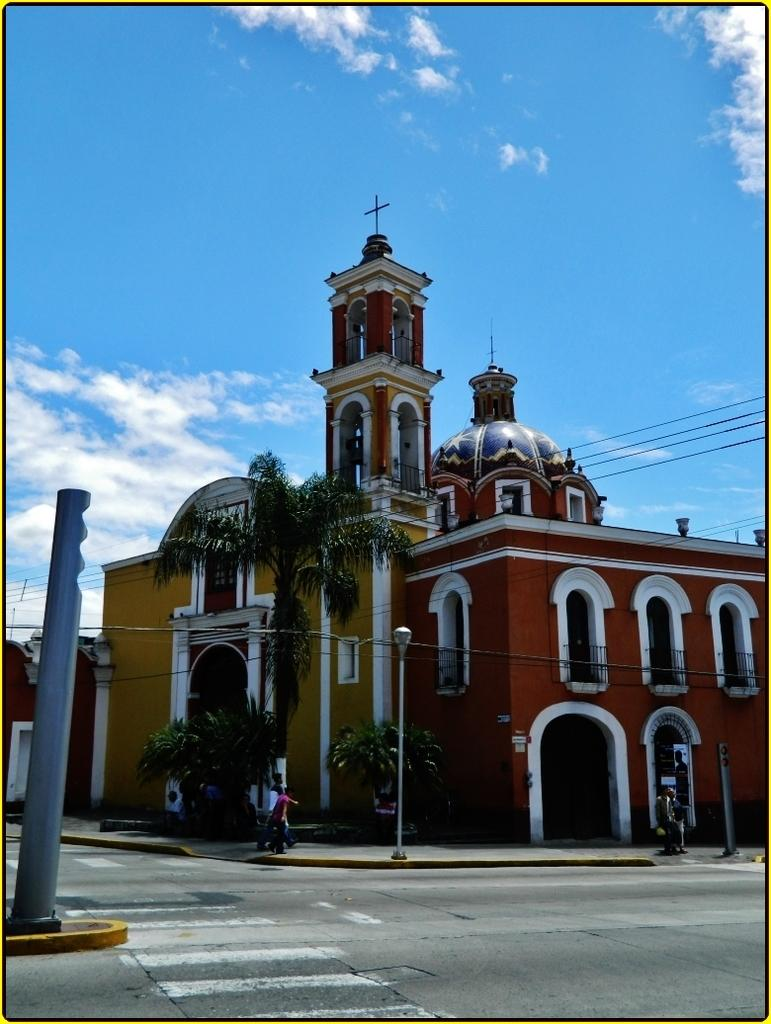What type of building is in the image? There is a brown building with a dome in the image. Where is the building located in the image? The building is in the front of the image. What is visible at the bottom of the image? There is a road in the front bottom side of the image. What is visible at the top of the image? The sky is visible at the top of the image. What can be seen in the sky? Clouds are present in the sky. What type of rhythm can be heard coming from the building in the image? There is no indication of sound or rhythm in the image, as it features a building with a dome and a road. 